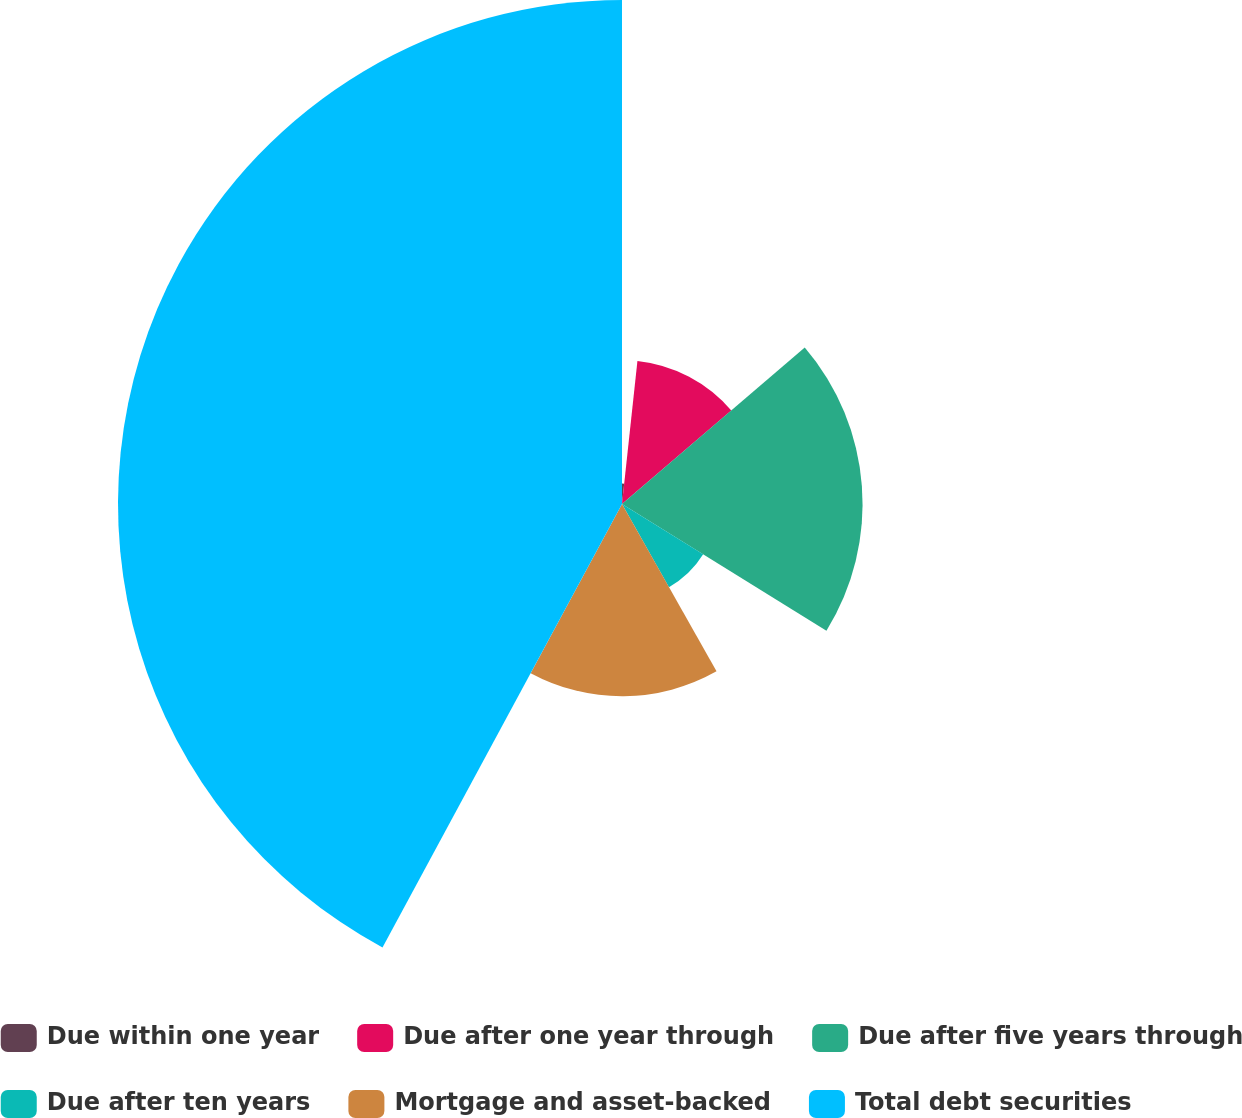Convert chart to OTSL. <chart><loc_0><loc_0><loc_500><loc_500><pie_chart><fcel>Due within one year<fcel>Due after one year through<fcel>Due after five years through<fcel>Due after ten years<fcel>Mortgage and asset-backed<fcel>Total debt securities<nl><fcel>1.71%<fcel>12.02%<fcel>20.1%<fcel>7.98%<fcel>16.06%<fcel>42.11%<nl></chart> 